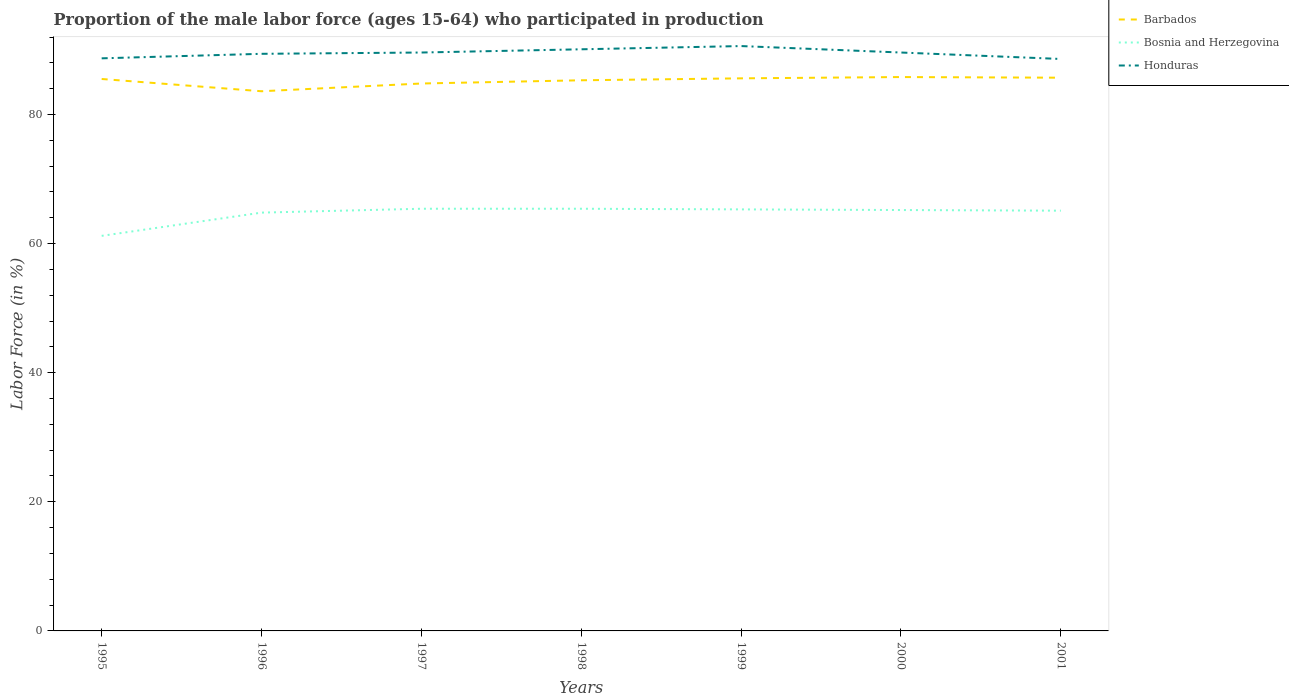Does the line corresponding to Barbados intersect with the line corresponding to Honduras?
Offer a very short reply. No. Across all years, what is the maximum proportion of the male labor force who participated in production in Barbados?
Provide a succinct answer. 83.6. In which year was the proportion of the male labor force who participated in production in Barbados maximum?
Your answer should be very brief. 1996. What is the total proportion of the male labor force who participated in production in Bosnia and Herzegovina in the graph?
Make the answer very short. -0.3. What is the difference between the highest and the second highest proportion of the male labor force who participated in production in Bosnia and Herzegovina?
Provide a succinct answer. 4.2. What is the difference between two consecutive major ticks on the Y-axis?
Keep it short and to the point. 20. Are the values on the major ticks of Y-axis written in scientific E-notation?
Provide a short and direct response. No. Where does the legend appear in the graph?
Your answer should be very brief. Top right. How many legend labels are there?
Provide a short and direct response. 3. How are the legend labels stacked?
Provide a succinct answer. Vertical. What is the title of the graph?
Ensure brevity in your answer.  Proportion of the male labor force (ages 15-64) who participated in production. Does "Panama" appear as one of the legend labels in the graph?
Offer a terse response. No. What is the Labor Force (in %) in Barbados in 1995?
Your answer should be very brief. 85.5. What is the Labor Force (in %) of Bosnia and Herzegovina in 1995?
Make the answer very short. 61.2. What is the Labor Force (in %) in Honduras in 1995?
Your answer should be very brief. 88.7. What is the Labor Force (in %) of Barbados in 1996?
Give a very brief answer. 83.6. What is the Labor Force (in %) in Bosnia and Herzegovina in 1996?
Provide a short and direct response. 64.8. What is the Labor Force (in %) in Honduras in 1996?
Offer a terse response. 89.4. What is the Labor Force (in %) of Barbados in 1997?
Make the answer very short. 84.8. What is the Labor Force (in %) of Bosnia and Herzegovina in 1997?
Make the answer very short. 65.4. What is the Labor Force (in %) of Honduras in 1997?
Provide a succinct answer. 89.6. What is the Labor Force (in %) in Barbados in 1998?
Your answer should be compact. 85.3. What is the Labor Force (in %) in Bosnia and Herzegovina in 1998?
Your response must be concise. 65.4. What is the Labor Force (in %) in Honduras in 1998?
Make the answer very short. 90.1. What is the Labor Force (in %) of Barbados in 1999?
Your answer should be compact. 85.6. What is the Labor Force (in %) in Bosnia and Herzegovina in 1999?
Provide a succinct answer. 65.3. What is the Labor Force (in %) in Honduras in 1999?
Your answer should be very brief. 90.6. What is the Labor Force (in %) in Barbados in 2000?
Provide a succinct answer. 85.8. What is the Labor Force (in %) in Bosnia and Herzegovina in 2000?
Your answer should be very brief. 65.2. What is the Labor Force (in %) in Honduras in 2000?
Your answer should be very brief. 89.6. What is the Labor Force (in %) of Barbados in 2001?
Offer a very short reply. 85.7. What is the Labor Force (in %) in Bosnia and Herzegovina in 2001?
Your response must be concise. 65.1. What is the Labor Force (in %) in Honduras in 2001?
Provide a short and direct response. 88.6. Across all years, what is the maximum Labor Force (in %) in Barbados?
Offer a terse response. 85.8. Across all years, what is the maximum Labor Force (in %) of Bosnia and Herzegovina?
Your answer should be compact. 65.4. Across all years, what is the maximum Labor Force (in %) in Honduras?
Offer a very short reply. 90.6. Across all years, what is the minimum Labor Force (in %) of Barbados?
Your answer should be very brief. 83.6. Across all years, what is the minimum Labor Force (in %) of Bosnia and Herzegovina?
Your answer should be compact. 61.2. Across all years, what is the minimum Labor Force (in %) of Honduras?
Offer a very short reply. 88.6. What is the total Labor Force (in %) in Barbados in the graph?
Provide a short and direct response. 596.3. What is the total Labor Force (in %) in Bosnia and Herzegovina in the graph?
Offer a very short reply. 452.4. What is the total Labor Force (in %) of Honduras in the graph?
Your answer should be compact. 626.6. What is the difference between the Labor Force (in %) in Barbados in 1995 and that in 1996?
Your answer should be compact. 1.9. What is the difference between the Labor Force (in %) in Honduras in 1995 and that in 1997?
Offer a very short reply. -0.9. What is the difference between the Labor Force (in %) in Bosnia and Herzegovina in 1995 and that in 1998?
Provide a succinct answer. -4.2. What is the difference between the Labor Force (in %) in Honduras in 1995 and that in 1998?
Give a very brief answer. -1.4. What is the difference between the Labor Force (in %) of Barbados in 1995 and that in 1999?
Offer a terse response. -0.1. What is the difference between the Labor Force (in %) of Bosnia and Herzegovina in 1995 and that in 1999?
Provide a succinct answer. -4.1. What is the difference between the Labor Force (in %) of Honduras in 1995 and that in 1999?
Offer a very short reply. -1.9. What is the difference between the Labor Force (in %) of Barbados in 1995 and that in 2000?
Provide a short and direct response. -0.3. What is the difference between the Labor Force (in %) in Bosnia and Herzegovina in 1995 and that in 2000?
Give a very brief answer. -4. What is the difference between the Labor Force (in %) in Barbados in 1995 and that in 2001?
Your answer should be very brief. -0.2. What is the difference between the Labor Force (in %) of Bosnia and Herzegovina in 1995 and that in 2001?
Your answer should be very brief. -3.9. What is the difference between the Labor Force (in %) in Barbados in 1996 and that in 1998?
Your answer should be compact. -1.7. What is the difference between the Labor Force (in %) in Bosnia and Herzegovina in 1996 and that in 1998?
Your answer should be very brief. -0.6. What is the difference between the Labor Force (in %) in Honduras in 1996 and that in 1998?
Offer a very short reply. -0.7. What is the difference between the Labor Force (in %) of Bosnia and Herzegovina in 1996 and that in 1999?
Give a very brief answer. -0.5. What is the difference between the Labor Force (in %) in Honduras in 1996 and that in 1999?
Offer a very short reply. -1.2. What is the difference between the Labor Force (in %) in Bosnia and Herzegovina in 1996 and that in 2000?
Keep it short and to the point. -0.4. What is the difference between the Labor Force (in %) in Barbados in 1996 and that in 2001?
Make the answer very short. -2.1. What is the difference between the Labor Force (in %) of Bosnia and Herzegovina in 1996 and that in 2001?
Provide a succinct answer. -0.3. What is the difference between the Labor Force (in %) of Barbados in 1997 and that in 1999?
Make the answer very short. -0.8. What is the difference between the Labor Force (in %) in Honduras in 1997 and that in 1999?
Your answer should be very brief. -1. What is the difference between the Labor Force (in %) of Barbados in 1997 and that in 2000?
Make the answer very short. -1. What is the difference between the Labor Force (in %) in Honduras in 1997 and that in 2000?
Give a very brief answer. 0. What is the difference between the Labor Force (in %) in Honduras in 1997 and that in 2001?
Make the answer very short. 1. What is the difference between the Labor Force (in %) in Barbados in 1998 and that in 1999?
Make the answer very short. -0.3. What is the difference between the Labor Force (in %) in Honduras in 1998 and that in 1999?
Offer a very short reply. -0.5. What is the difference between the Labor Force (in %) in Honduras in 1998 and that in 2000?
Offer a very short reply. 0.5. What is the difference between the Labor Force (in %) of Barbados in 1998 and that in 2001?
Your response must be concise. -0.4. What is the difference between the Labor Force (in %) in Honduras in 1998 and that in 2001?
Your answer should be compact. 1.5. What is the difference between the Labor Force (in %) of Honduras in 1999 and that in 2000?
Give a very brief answer. 1. What is the difference between the Labor Force (in %) in Barbados in 1999 and that in 2001?
Your answer should be compact. -0.1. What is the difference between the Labor Force (in %) in Honduras in 1999 and that in 2001?
Provide a short and direct response. 2. What is the difference between the Labor Force (in %) of Barbados in 2000 and that in 2001?
Keep it short and to the point. 0.1. What is the difference between the Labor Force (in %) in Bosnia and Herzegovina in 2000 and that in 2001?
Provide a succinct answer. 0.1. What is the difference between the Labor Force (in %) of Barbados in 1995 and the Labor Force (in %) of Bosnia and Herzegovina in 1996?
Give a very brief answer. 20.7. What is the difference between the Labor Force (in %) of Bosnia and Herzegovina in 1995 and the Labor Force (in %) of Honduras in 1996?
Keep it short and to the point. -28.2. What is the difference between the Labor Force (in %) in Barbados in 1995 and the Labor Force (in %) in Bosnia and Herzegovina in 1997?
Give a very brief answer. 20.1. What is the difference between the Labor Force (in %) in Bosnia and Herzegovina in 1995 and the Labor Force (in %) in Honduras in 1997?
Keep it short and to the point. -28.4. What is the difference between the Labor Force (in %) of Barbados in 1995 and the Labor Force (in %) of Bosnia and Herzegovina in 1998?
Your response must be concise. 20.1. What is the difference between the Labor Force (in %) in Bosnia and Herzegovina in 1995 and the Labor Force (in %) in Honduras in 1998?
Your answer should be compact. -28.9. What is the difference between the Labor Force (in %) in Barbados in 1995 and the Labor Force (in %) in Bosnia and Herzegovina in 1999?
Give a very brief answer. 20.2. What is the difference between the Labor Force (in %) of Barbados in 1995 and the Labor Force (in %) of Honduras in 1999?
Ensure brevity in your answer.  -5.1. What is the difference between the Labor Force (in %) of Bosnia and Herzegovina in 1995 and the Labor Force (in %) of Honduras in 1999?
Provide a short and direct response. -29.4. What is the difference between the Labor Force (in %) in Barbados in 1995 and the Labor Force (in %) in Bosnia and Herzegovina in 2000?
Ensure brevity in your answer.  20.3. What is the difference between the Labor Force (in %) of Barbados in 1995 and the Labor Force (in %) of Honduras in 2000?
Your response must be concise. -4.1. What is the difference between the Labor Force (in %) in Bosnia and Herzegovina in 1995 and the Labor Force (in %) in Honduras in 2000?
Provide a short and direct response. -28.4. What is the difference between the Labor Force (in %) of Barbados in 1995 and the Labor Force (in %) of Bosnia and Herzegovina in 2001?
Provide a short and direct response. 20.4. What is the difference between the Labor Force (in %) of Barbados in 1995 and the Labor Force (in %) of Honduras in 2001?
Provide a succinct answer. -3.1. What is the difference between the Labor Force (in %) in Bosnia and Herzegovina in 1995 and the Labor Force (in %) in Honduras in 2001?
Give a very brief answer. -27.4. What is the difference between the Labor Force (in %) of Barbados in 1996 and the Labor Force (in %) of Bosnia and Herzegovina in 1997?
Your answer should be compact. 18.2. What is the difference between the Labor Force (in %) in Bosnia and Herzegovina in 1996 and the Labor Force (in %) in Honduras in 1997?
Provide a succinct answer. -24.8. What is the difference between the Labor Force (in %) in Barbados in 1996 and the Labor Force (in %) in Bosnia and Herzegovina in 1998?
Your answer should be compact. 18.2. What is the difference between the Labor Force (in %) of Barbados in 1996 and the Labor Force (in %) of Honduras in 1998?
Ensure brevity in your answer.  -6.5. What is the difference between the Labor Force (in %) of Bosnia and Herzegovina in 1996 and the Labor Force (in %) of Honduras in 1998?
Provide a short and direct response. -25.3. What is the difference between the Labor Force (in %) of Bosnia and Herzegovina in 1996 and the Labor Force (in %) of Honduras in 1999?
Your answer should be compact. -25.8. What is the difference between the Labor Force (in %) in Barbados in 1996 and the Labor Force (in %) in Honduras in 2000?
Your answer should be compact. -6. What is the difference between the Labor Force (in %) in Bosnia and Herzegovina in 1996 and the Labor Force (in %) in Honduras in 2000?
Your answer should be very brief. -24.8. What is the difference between the Labor Force (in %) of Barbados in 1996 and the Labor Force (in %) of Bosnia and Herzegovina in 2001?
Keep it short and to the point. 18.5. What is the difference between the Labor Force (in %) in Barbados in 1996 and the Labor Force (in %) in Honduras in 2001?
Provide a succinct answer. -5. What is the difference between the Labor Force (in %) in Bosnia and Herzegovina in 1996 and the Labor Force (in %) in Honduras in 2001?
Offer a terse response. -23.8. What is the difference between the Labor Force (in %) of Barbados in 1997 and the Labor Force (in %) of Bosnia and Herzegovina in 1998?
Offer a very short reply. 19.4. What is the difference between the Labor Force (in %) in Barbados in 1997 and the Labor Force (in %) in Honduras in 1998?
Provide a succinct answer. -5.3. What is the difference between the Labor Force (in %) in Bosnia and Herzegovina in 1997 and the Labor Force (in %) in Honduras in 1998?
Your answer should be very brief. -24.7. What is the difference between the Labor Force (in %) in Bosnia and Herzegovina in 1997 and the Labor Force (in %) in Honduras in 1999?
Keep it short and to the point. -25.2. What is the difference between the Labor Force (in %) in Barbados in 1997 and the Labor Force (in %) in Bosnia and Herzegovina in 2000?
Your answer should be compact. 19.6. What is the difference between the Labor Force (in %) of Bosnia and Herzegovina in 1997 and the Labor Force (in %) of Honduras in 2000?
Ensure brevity in your answer.  -24.2. What is the difference between the Labor Force (in %) in Bosnia and Herzegovina in 1997 and the Labor Force (in %) in Honduras in 2001?
Your response must be concise. -23.2. What is the difference between the Labor Force (in %) of Barbados in 1998 and the Labor Force (in %) of Bosnia and Herzegovina in 1999?
Your answer should be compact. 20. What is the difference between the Labor Force (in %) of Barbados in 1998 and the Labor Force (in %) of Honduras in 1999?
Keep it short and to the point. -5.3. What is the difference between the Labor Force (in %) in Bosnia and Herzegovina in 1998 and the Labor Force (in %) in Honduras in 1999?
Make the answer very short. -25.2. What is the difference between the Labor Force (in %) of Barbados in 1998 and the Labor Force (in %) of Bosnia and Herzegovina in 2000?
Provide a succinct answer. 20.1. What is the difference between the Labor Force (in %) in Barbados in 1998 and the Labor Force (in %) in Honduras in 2000?
Provide a succinct answer. -4.3. What is the difference between the Labor Force (in %) in Bosnia and Herzegovina in 1998 and the Labor Force (in %) in Honduras in 2000?
Your answer should be compact. -24.2. What is the difference between the Labor Force (in %) in Barbados in 1998 and the Labor Force (in %) in Bosnia and Herzegovina in 2001?
Provide a short and direct response. 20.2. What is the difference between the Labor Force (in %) in Bosnia and Herzegovina in 1998 and the Labor Force (in %) in Honduras in 2001?
Make the answer very short. -23.2. What is the difference between the Labor Force (in %) in Barbados in 1999 and the Labor Force (in %) in Bosnia and Herzegovina in 2000?
Provide a short and direct response. 20.4. What is the difference between the Labor Force (in %) of Barbados in 1999 and the Labor Force (in %) of Honduras in 2000?
Provide a short and direct response. -4. What is the difference between the Labor Force (in %) in Bosnia and Herzegovina in 1999 and the Labor Force (in %) in Honduras in 2000?
Offer a terse response. -24.3. What is the difference between the Labor Force (in %) in Bosnia and Herzegovina in 1999 and the Labor Force (in %) in Honduras in 2001?
Your response must be concise. -23.3. What is the difference between the Labor Force (in %) in Barbados in 2000 and the Labor Force (in %) in Bosnia and Herzegovina in 2001?
Provide a succinct answer. 20.7. What is the difference between the Labor Force (in %) in Barbados in 2000 and the Labor Force (in %) in Honduras in 2001?
Give a very brief answer. -2.8. What is the difference between the Labor Force (in %) in Bosnia and Herzegovina in 2000 and the Labor Force (in %) in Honduras in 2001?
Your answer should be compact. -23.4. What is the average Labor Force (in %) in Barbados per year?
Offer a very short reply. 85.19. What is the average Labor Force (in %) in Bosnia and Herzegovina per year?
Give a very brief answer. 64.63. What is the average Labor Force (in %) of Honduras per year?
Your response must be concise. 89.51. In the year 1995, what is the difference between the Labor Force (in %) in Barbados and Labor Force (in %) in Bosnia and Herzegovina?
Your response must be concise. 24.3. In the year 1995, what is the difference between the Labor Force (in %) in Barbados and Labor Force (in %) in Honduras?
Offer a terse response. -3.2. In the year 1995, what is the difference between the Labor Force (in %) in Bosnia and Herzegovina and Labor Force (in %) in Honduras?
Your response must be concise. -27.5. In the year 1996, what is the difference between the Labor Force (in %) in Bosnia and Herzegovina and Labor Force (in %) in Honduras?
Keep it short and to the point. -24.6. In the year 1997, what is the difference between the Labor Force (in %) in Bosnia and Herzegovina and Labor Force (in %) in Honduras?
Offer a very short reply. -24.2. In the year 1998, what is the difference between the Labor Force (in %) in Barbados and Labor Force (in %) in Bosnia and Herzegovina?
Offer a terse response. 19.9. In the year 1998, what is the difference between the Labor Force (in %) in Bosnia and Herzegovina and Labor Force (in %) in Honduras?
Offer a very short reply. -24.7. In the year 1999, what is the difference between the Labor Force (in %) in Barbados and Labor Force (in %) in Bosnia and Herzegovina?
Give a very brief answer. 20.3. In the year 1999, what is the difference between the Labor Force (in %) of Barbados and Labor Force (in %) of Honduras?
Provide a succinct answer. -5. In the year 1999, what is the difference between the Labor Force (in %) of Bosnia and Herzegovina and Labor Force (in %) of Honduras?
Keep it short and to the point. -25.3. In the year 2000, what is the difference between the Labor Force (in %) in Barbados and Labor Force (in %) in Bosnia and Herzegovina?
Ensure brevity in your answer.  20.6. In the year 2000, what is the difference between the Labor Force (in %) of Bosnia and Herzegovina and Labor Force (in %) of Honduras?
Your answer should be compact. -24.4. In the year 2001, what is the difference between the Labor Force (in %) of Barbados and Labor Force (in %) of Bosnia and Herzegovina?
Ensure brevity in your answer.  20.6. In the year 2001, what is the difference between the Labor Force (in %) of Barbados and Labor Force (in %) of Honduras?
Ensure brevity in your answer.  -2.9. In the year 2001, what is the difference between the Labor Force (in %) of Bosnia and Herzegovina and Labor Force (in %) of Honduras?
Ensure brevity in your answer.  -23.5. What is the ratio of the Labor Force (in %) of Barbados in 1995 to that in 1996?
Your answer should be compact. 1.02. What is the ratio of the Labor Force (in %) in Bosnia and Herzegovina in 1995 to that in 1996?
Your answer should be compact. 0.94. What is the ratio of the Labor Force (in %) of Honduras in 1995 to that in 1996?
Your response must be concise. 0.99. What is the ratio of the Labor Force (in %) in Barbados in 1995 to that in 1997?
Make the answer very short. 1.01. What is the ratio of the Labor Force (in %) of Bosnia and Herzegovina in 1995 to that in 1997?
Provide a succinct answer. 0.94. What is the ratio of the Labor Force (in %) of Honduras in 1995 to that in 1997?
Keep it short and to the point. 0.99. What is the ratio of the Labor Force (in %) in Barbados in 1995 to that in 1998?
Offer a very short reply. 1. What is the ratio of the Labor Force (in %) in Bosnia and Herzegovina in 1995 to that in 1998?
Your response must be concise. 0.94. What is the ratio of the Labor Force (in %) of Honduras in 1995 to that in 1998?
Your response must be concise. 0.98. What is the ratio of the Labor Force (in %) of Barbados in 1995 to that in 1999?
Offer a very short reply. 1. What is the ratio of the Labor Force (in %) of Bosnia and Herzegovina in 1995 to that in 1999?
Keep it short and to the point. 0.94. What is the ratio of the Labor Force (in %) in Barbados in 1995 to that in 2000?
Offer a terse response. 1. What is the ratio of the Labor Force (in %) in Bosnia and Herzegovina in 1995 to that in 2000?
Your answer should be very brief. 0.94. What is the ratio of the Labor Force (in %) in Honduras in 1995 to that in 2000?
Keep it short and to the point. 0.99. What is the ratio of the Labor Force (in %) of Barbados in 1995 to that in 2001?
Ensure brevity in your answer.  1. What is the ratio of the Labor Force (in %) of Bosnia and Herzegovina in 1995 to that in 2001?
Your response must be concise. 0.94. What is the ratio of the Labor Force (in %) of Barbados in 1996 to that in 1997?
Make the answer very short. 0.99. What is the ratio of the Labor Force (in %) in Bosnia and Herzegovina in 1996 to that in 1997?
Offer a terse response. 0.99. What is the ratio of the Labor Force (in %) of Honduras in 1996 to that in 1997?
Your response must be concise. 1. What is the ratio of the Labor Force (in %) of Barbados in 1996 to that in 1998?
Offer a terse response. 0.98. What is the ratio of the Labor Force (in %) in Honduras in 1996 to that in 1998?
Your answer should be very brief. 0.99. What is the ratio of the Labor Force (in %) in Barbados in 1996 to that in 1999?
Make the answer very short. 0.98. What is the ratio of the Labor Force (in %) in Honduras in 1996 to that in 1999?
Ensure brevity in your answer.  0.99. What is the ratio of the Labor Force (in %) of Barbados in 1996 to that in 2000?
Ensure brevity in your answer.  0.97. What is the ratio of the Labor Force (in %) in Honduras in 1996 to that in 2000?
Make the answer very short. 1. What is the ratio of the Labor Force (in %) of Barbados in 1996 to that in 2001?
Ensure brevity in your answer.  0.98. What is the ratio of the Labor Force (in %) in Bosnia and Herzegovina in 1996 to that in 2001?
Your answer should be very brief. 1. What is the ratio of the Labor Force (in %) in Barbados in 1997 to that in 1998?
Give a very brief answer. 0.99. What is the ratio of the Labor Force (in %) in Bosnia and Herzegovina in 1997 to that in 1998?
Your answer should be compact. 1. What is the ratio of the Labor Force (in %) in Bosnia and Herzegovina in 1997 to that in 1999?
Keep it short and to the point. 1. What is the ratio of the Labor Force (in %) of Barbados in 1997 to that in 2000?
Your answer should be very brief. 0.99. What is the ratio of the Labor Force (in %) of Honduras in 1997 to that in 2000?
Make the answer very short. 1. What is the ratio of the Labor Force (in %) in Barbados in 1997 to that in 2001?
Give a very brief answer. 0.99. What is the ratio of the Labor Force (in %) of Honduras in 1997 to that in 2001?
Keep it short and to the point. 1.01. What is the ratio of the Labor Force (in %) in Barbados in 1998 to that in 1999?
Your answer should be compact. 1. What is the ratio of the Labor Force (in %) of Bosnia and Herzegovina in 1998 to that in 1999?
Your answer should be very brief. 1. What is the ratio of the Labor Force (in %) in Honduras in 1998 to that in 1999?
Keep it short and to the point. 0.99. What is the ratio of the Labor Force (in %) in Bosnia and Herzegovina in 1998 to that in 2000?
Keep it short and to the point. 1. What is the ratio of the Labor Force (in %) in Honduras in 1998 to that in 2000?
Offer a terse response. 1.01. What is the ratio of the Labor Force (in %) of Honduras in 1998 to that in 2001?
Your response must be concise. 1.02. What is the ratio of the Labor Force (in %) in Honduras in 1999 to that in 2000?
Ensure brevity in your answer.  1.01. What is the ratio of the Labor Force (in %) of Barbados in 1999 to that in 2001?
Offer a terse response. 1. What is the ratio of the Labor Force (in %) in Honduras in 1999 to that in 2001?
Offer a terse response. 1.02. What is the ratio of the Labor Force (in %) in Honduras in 2000 to that in 2001?
Your answer should be very brief. 1.01. What is the difference between the highest and the second highest Labor Force (in %) in Barbados?
Offer a terse response. 0.1. What is the difference between the highest and the second highest Labor Force (in %) of Bosnia and Herzegovina?
Give a very brief answer. 0. What is the difference between the highest and the second highest Labor Force (in %) of Honduras?
Your answer should be compact. 0.5. What is the difference between the highest and the lowest Labor Force (in %) of Honduras?
Offer a terse response. 2. 